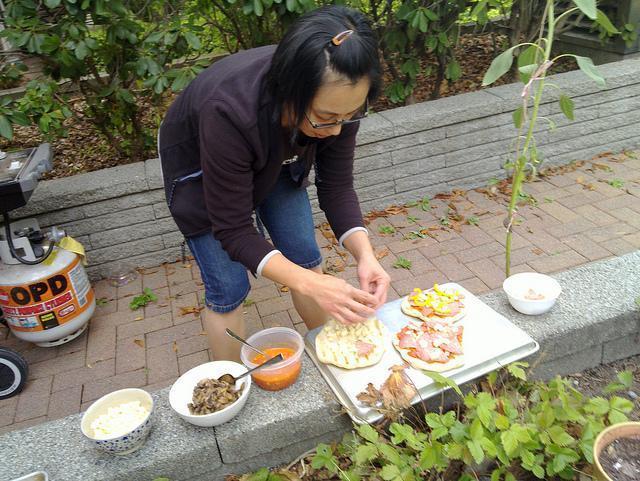How many bowls are on the wall?
Give a very brief answer. 4. How many pizzas are visible?
Give a very brief answer. 2. How many bowls are in the photo?
Give a very brief answer. 3. 